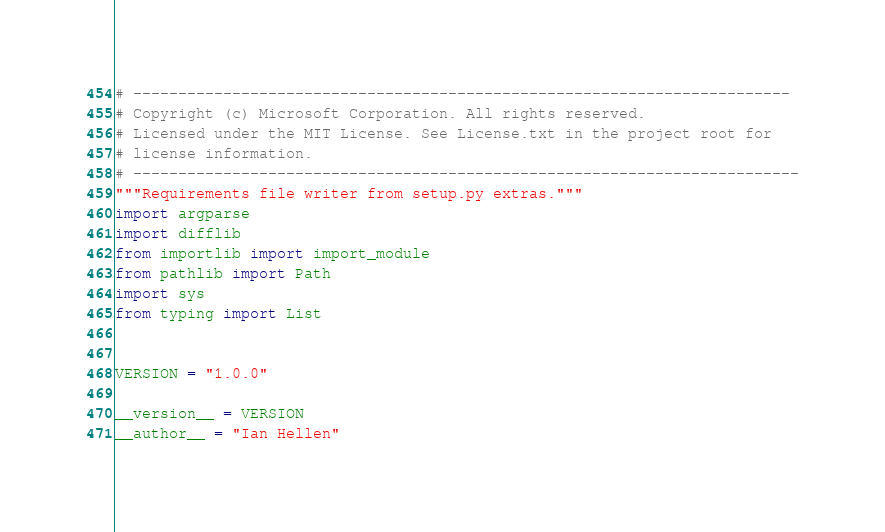Convert code to text. <code><loc_0><loc_0><loc_500><loc_500><_Python_># -------------------------------------------------------------------------
# Copyright (c) Microsoft Corporation. All rights reserved.
# Licensed under the MIT License. See License.txt in the project root for
# license information.
# --------------------------------------------------------------------------
"""Requirements file writer from setup.py extras."""
import argparse
import difflib
from importlib import import_module
from pathlib import Path
import sys
from typing import List


VERSION = "1.0.0"

__version__ = VERSION
__author__ = "Ian Hellen"

</code> 